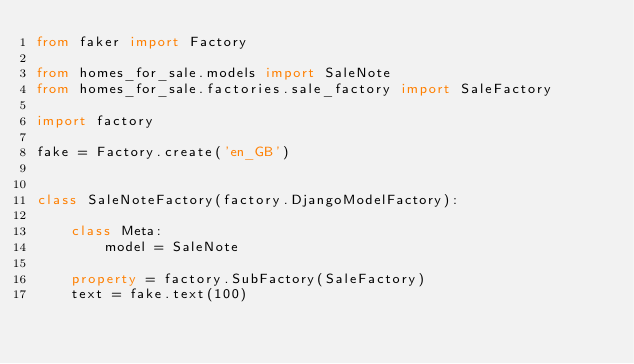Convert code to text. <code><loc_0><loc_0><loc_500><loc_500><_Python_>from faker import Factory

from homes_for_sale.models import SaleNote
from homes_for_sale.factories.sale_factory import SaleFactory

import factory

fake = Factory.create('en_GB')


class SaleNoteFactory(factory.DjangoModelFactory):

    class Meta:
        model = SaleNote

    property = factory.SubFactory(SaleFactory)
    text = fake.text(100)
</code> 